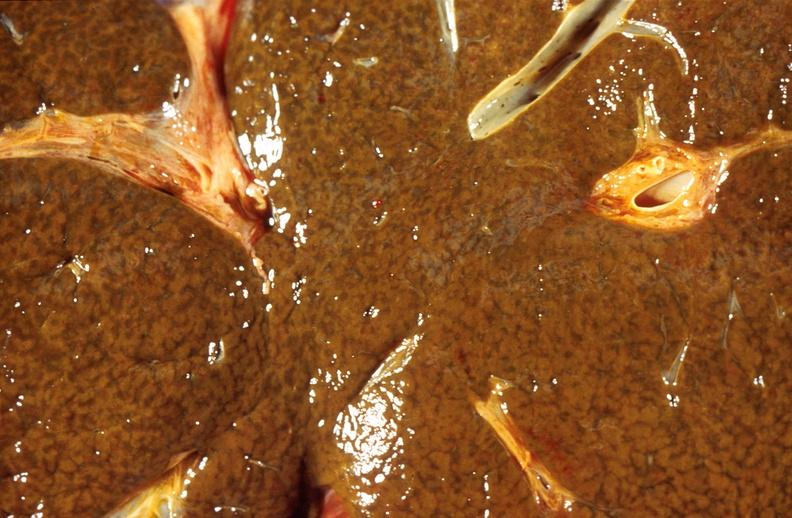s eye present?
Answer the question using a single word or phrase. No 